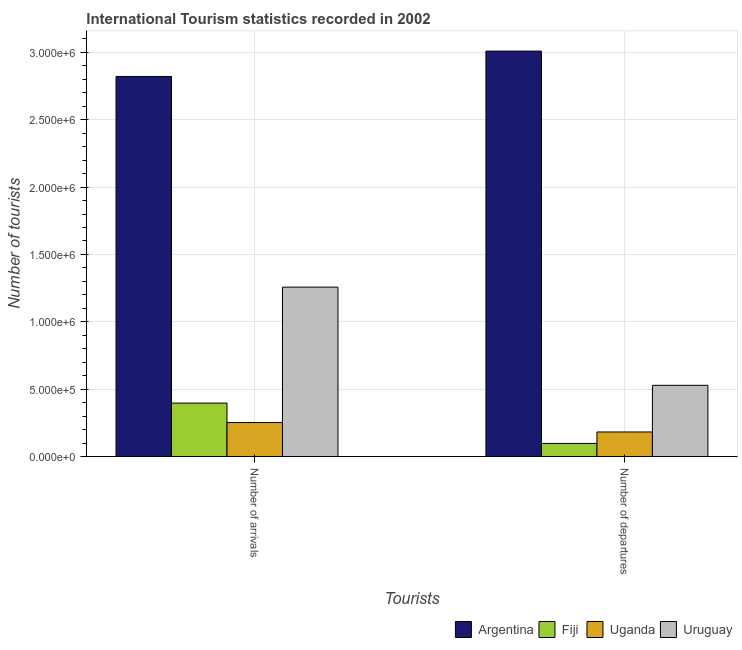How many groups of bars are there?
Your answer should be very brief. 2. Are the number of bars per tick equal to the number of legend labels?
Offer a very short reply. Yes. Are the number of bars on each tick of the X-axis equal?
Offer a terse response. Yes. How many bars are there on the 1st tick from the left?
Offer a terse response. 4. How many bars are there on the 1st tick from the right?
Provide a short and direct response. 4. What is the label of the 1st group of bars from the left?
Give a very brief answer. Number of arrivals. What is the number of tourist departures in Fiji?
Provide a short and direct response. 9.90e+04. Across all countries, what is the maximum number of tourist departures?
Offer a terse response. 3.01e+06. Across all countries, what is the minimum number of tourist arrivals?
Offer a very short reply. 2.54e+05. In which country was the number of tourist arrivals maximum?
Make the answer very short. Argentina. In which country was the number of tourist arrivals minimum?
Give a very brief answer. Uganda. What is the total number of tourist departures in the graph?
Your answer should be very brief. 3.82e+06. What is the difference between the number of tourist arrivals in Uruguay and that in Argentina?
Ensure brevity in your answer.  -1.56e+06. What is the difference between the number of tourist departures in Uruguay and the number of tourist arrivals in Uganda?
Offer a very short reply. 2.76e+05. What is the average number of tourist arrivals per country?
Make the answer very short. 1.18e+06. What is the difference between the number of tourist arrivals and number of tourist departures in Uruguay?
Provide a short and direct response. 7.28e+05. What is the ratio of the number of tourist departures in Uruguay to that in Argentina?
Your response must be concise. 0.18. Is the number of tourist arrivals in Uruguay less than that in Argentina?
Provide a short and direct response. Yes. What does the 3rd bar from the right in Number of arrivals represents?
Your answer should be compact. Fiji. How are the legend labels stacked?
Provide a succinct answer. Horizontal. What is the title of the graph?
Your response must be concise. International Tourism statistics recorded in 2002. Does "Chad" appear as one of the legend labels in the graph?
Provide a short and direct response. No. What is the label or title of the X-axis?
Provide a short and direct response. Tourists. What is the label or title of the Y-axis?
Offer a very short reply. Number of tourists. What is the Number of tourists in Argentina in Number of arrivals?
Your answer should be very brief. 2.82e+06. What is the Number of tourists in Fiji in Number of arrivals?
Give a very brief answer. 3.98e+05. What is the Number of tourists in Uganda in Number of arrivals?
Your response must be concise. 2.54e+05. What is the Number of tourists in Uruguay in Number of arrivals?
Your response must be concise. 1.26e+06. What is the Number of tourists of Argentina in Number of departures?
Ensure brevity in your answer.  3.01e+06. What is the Number of tourists of Fiji in Number of departures?
Offer a terse response. 9.90e+04. What is the Number of tourists in Uganda in Number of departures?
Make the answer very short. 1.84e+05. What is the Number of tourists of Uruguay in Number of departures?
Offer a terse response. 5.30e+05. Across all Tourists, what is the maximum Number of tourists in Argentina?
Provide a succinct answer. 3.01e+06. Across all Tourists, what is the maximum Number of tourists of Fiji?
Your response must be concise. 3.98e+05. Across all Tourists, what is the maximum Number of tourists in Uganda?
Provide a short and direct response. 2.54e+05. Across all Tourists, what is the maximum Number of tourists in Uruguay?
Provide a short and direct response. 1.26e+06. Across all Tourists, what is the minimum Number of tourists of Argentina?
Your response must be concise. 2.82e+06. Across all Tourists, what is the minimum Number of tourists of Fiji?
Give a very brief answer. 9.90e+04. Across all Tourists, what is the minimum Number of tourists of Uganda?
Give a very brief answer. 1.84e+05. Across all Tourists, what is the minimum Number of tourists of Uruguay?
Your answer should be very brief. 5.30e+05. What is the total Number of tourists of Argentina in the graph?
Give a very brief answer. 5.83e+06. What is the total Number of tourists of Fiji in the graph?
Offer a very short reply. 4.97e+05. What is the total Number of tourists in Uganda in the graph?
Offer a very short reply. 4.38e+05. What is the total Number of tourists in Uruguay in the graph?
Offer a terse response. 1.79e+06. What is the difference between the Number of tourists in Argentina in Number of arrivals and that in Number of departures?
Keep it short and to the point. -1.88e+05. What is the difference between the Number of tourists in Fiji in Number of arrivals and that in Number of departures?
Your answer should be compact. 2.99e+05. What is the difference between the Number of tourists in Uruguay in Number of arrivals and that in Number of departures?
Offer a very short reply. 7.28e+05. What is the difference between the Number of tourists of Argentina in Number of arrivals and the Number of tourists of Fiji in Number of departures?
Make the answer very short. 2.72e+06. What is the difference between the Number of tourists in Argentina in Number of arrivals and the Number of tourists in Uganda in Number of departures?
Offer a very short reply. 2.64e+06. What is the difference between the Number of tourists in Argentina in Number of arrivals and the Number of tourists in Uruguay in Number of departures?
Your response must be concise. 2.29e+06. What is the difference between the Number of tourists of Fiji in Number of arrivals and the Number of tourists of Uganda in Number of departures?
Provide a short and direct response. 2.14e+05. What is the difference between the Number of tourists of Fiji in Number of arrivals and the Number of tourists of Uruguay in Number of departures?
Provide a succinct answer. -1.32e+05. What is the difference between the Number of tourists in Uganda in Number of arrivals and the Number of tourists in Uruguay in Number of departures?
Make the answer very short. -2.76e+05. What is the average Number of tourists of Argentina per Tourists?
Make the answer very short. 2.91e+06. What is the average Number of tourists in Fiji per Tourists?
Give a very brief answer. 2.48e+05. What is the average Number of tourists in Uganda per Tourists?
Keep it short and to the point. 2.19e+05. What is the average Number of tourists of Uruguay per Tourists?
Keep it short and to the point. 8.94e+05. What is the difference between the Number of tourists of Argentina and Number of tourists of Fiji in Number of arrivals?
Your response must be concise. 2.42e+06. What is the difference between the Number of tourists in Argentina and Number of tourists in Uganda in Number of arrivals?
Offer a terse response. 2.57e+06. What is the difference between the Number of tourists of Argentina and Number of tourists of Uruguay in Number of arrivals?
Keep it short and to the point. 1.56e+06. What is the difference between the Number of tourists of Fiji and Number of tourists of Uganda in Number of arrivals?
Offer a terse response. 1.44e+05. What is the difference between the Number of tourists in Fiji and Number of tourists in Uruguay in Number of arrivals?
Offer a very short reply. -8.60e+05. What is the difference between the Number of tourists of Uganda and Number of tourists of Uruguay in Number of arrivals?
Give a very brief answer. -1.00e+06. What is the difference between the Number of tourists of Argentina and Number of tourists of Fiji in Number of departures?
Offer a very short reply. 2.91e+06. What is the difference between the Number of tourists of Argentina and Number of tourists of Uganda in Number of departures?
Your response must be concise. 2.82e+06. What is the difference between the Number of tourists of Argentina and Number of tourists of Uruguay in Number of departures?
Give a very brief answer. 2.48e+06. What is the difference between the Number of tourists in Fiji and Number of tourists in Uganda in Number of departures?
Make the answer very short. -8.50e+04. What is the difference between the Number of tourists in Fiji and Number of tourists in Uruguay in Number of departures?
Offer a terse response. -4.31e+05. What is the difference between the Number of tourists of Uganda and Number of tourists of Uruguay in Number of departures?
Provide a short and direct response. -3.46e+05. What is the ratio of the Number of tourists in Argentina in Number of arrivals to that in Number of departures?
Provide a succinct answer. 0.94. What is the ratio of the Number of tourists of Fiji in Number of arrivals to that in Number of departures?
Offer a terse response. 4.02. What is the ratio of the Number of tourists in Uganda in Number of arrivals to that in Number of departures?
Ensure brevity in your answer.  1.38. What is the ratio of the Number of tourists of Uruguay in Number of arrivals to that in Number of departures?
Give a very brief answer. 2.37. What is the difference between the highest and the second highest Number of tourists of Argentina?
Your answer should be very brief. 1.88e+05. What is the difference between the highest and the second highest Number of tourists of Fiji?
Give a very brief answer. 2.99e+05. What is the difference between the highest and the second highest Number of tourists of Uganda?
Your response must be concise. 7.00e+04. What is the difference between the highest and the second highest Number of tourists of Uruguay?
Offer a terse response. 7.28e+05. What is the difference between the highest and the lowest Number of tourists in Argentina?
Offer a very short reply. 1.88e+05. What is the difference between the highest and the lowest Number of tourists of Fiji?
Ensure brevity in your answer.  2.99e+05. What is the difference between the highest and the lowest Number of tourists in Uruguay?
Provide a succinct answer. 7.28e+05. 